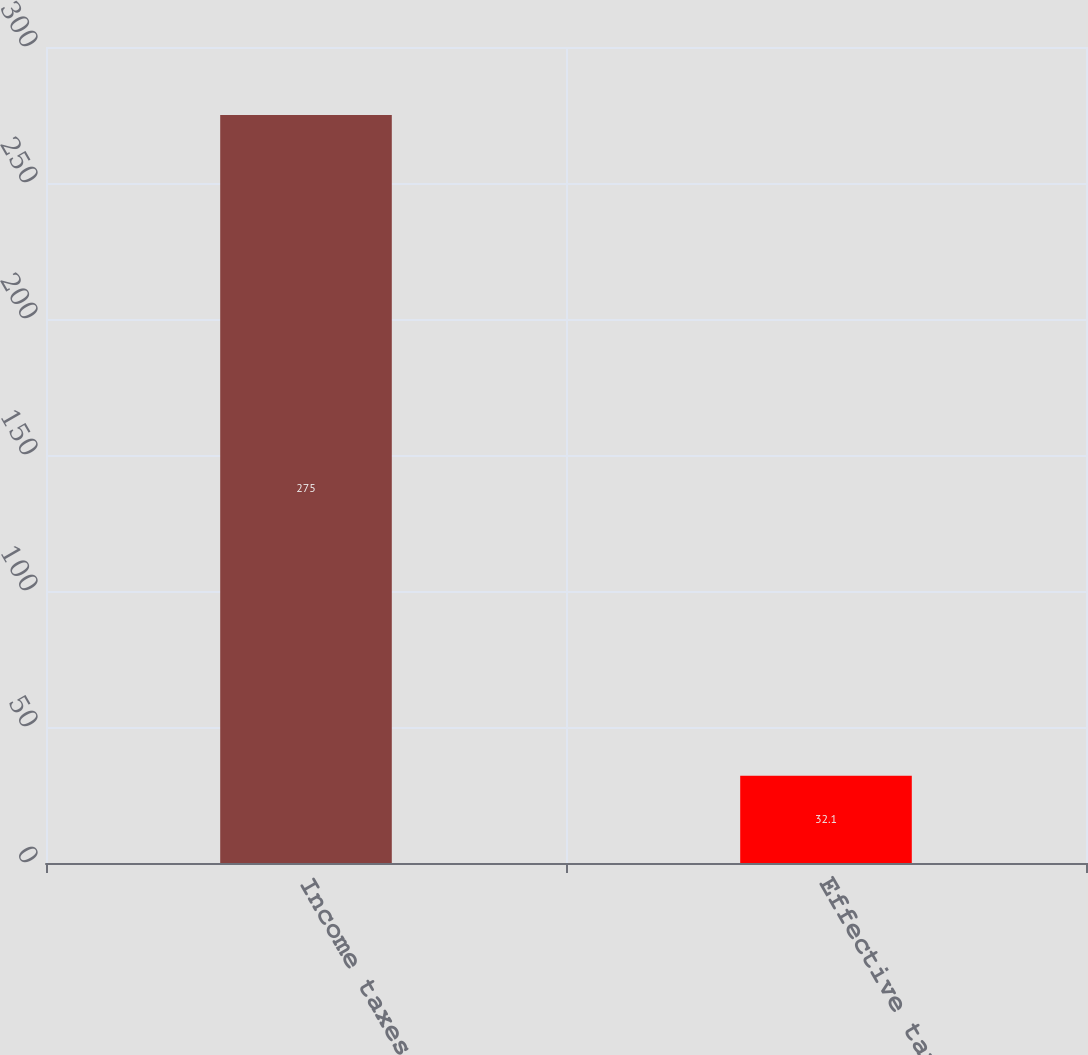Convert chart to OTSL. <chart><loc_0><loc_0><loc_500><loc_500><bar_chart><fcel>Income taxes<fcel>Effective tax rate<nl><fcel>275<fcel>32.1<nl></chart> 